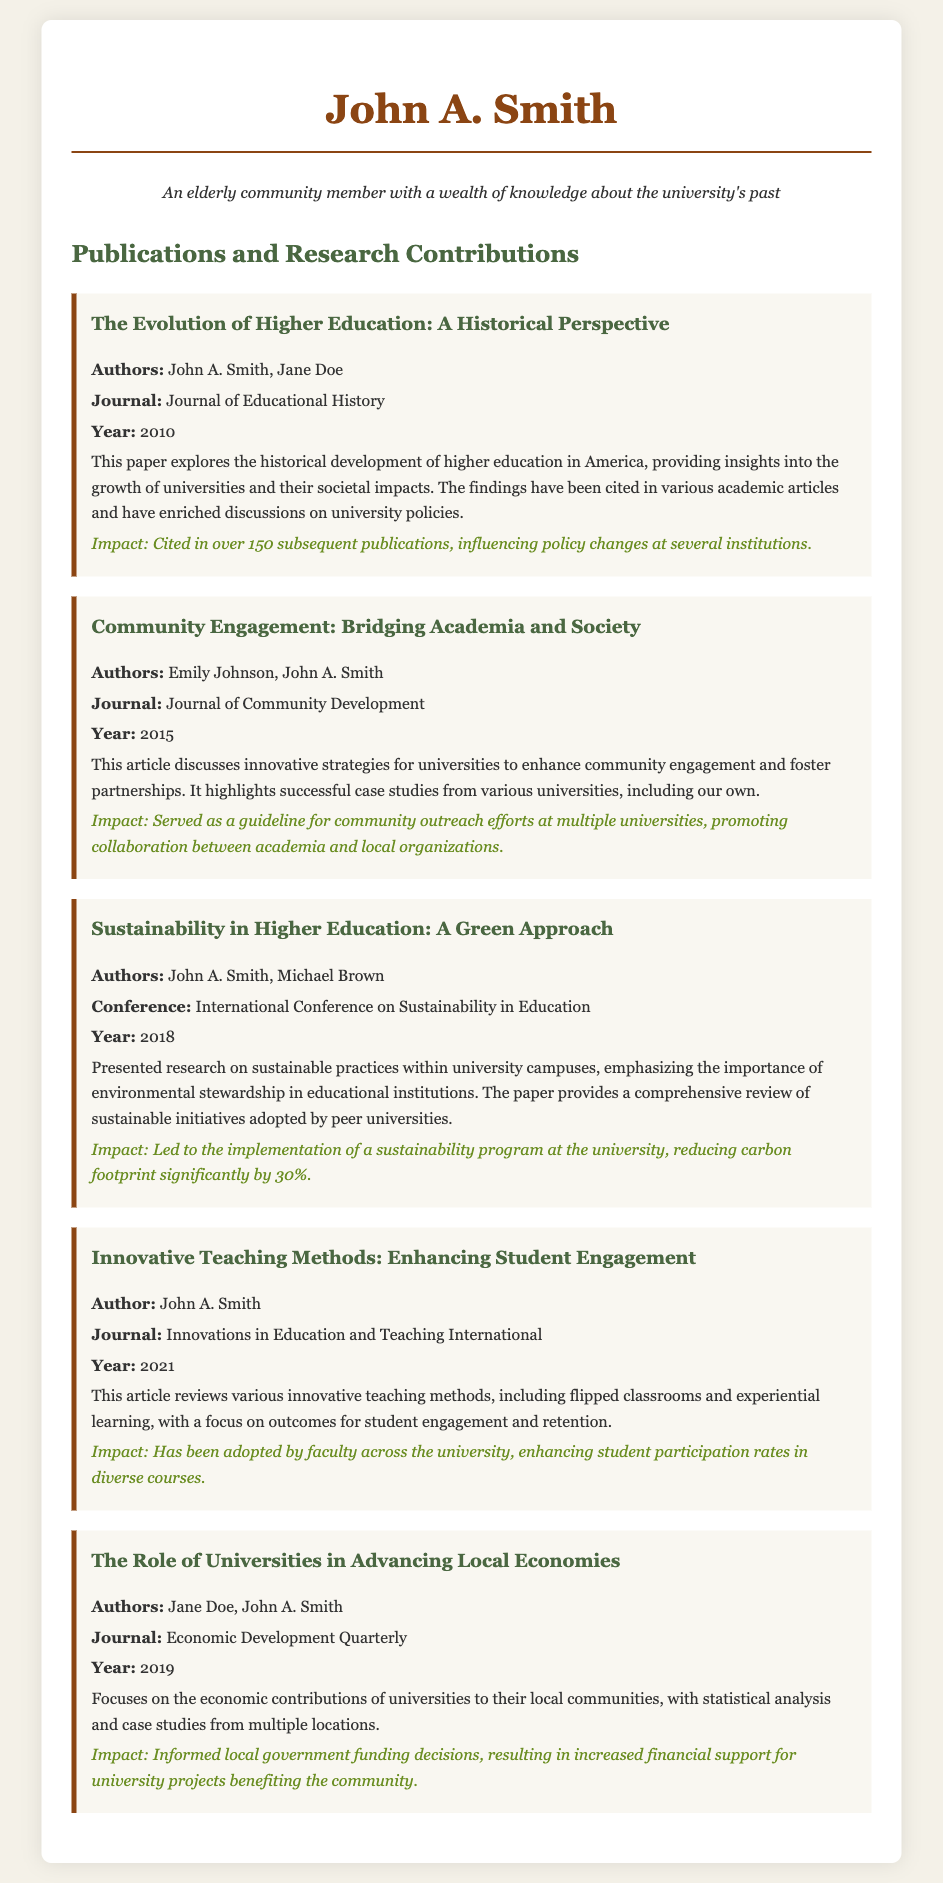What is the title of the first publication? The title of the first publication is provided in the document and is "The Evolution of Higher Education: A Historical Perspective."
Answer: The Evolution of Higher Education: A Historical Perspective Who are the co-authors of the publication titled "Community Engagement: Bridging Academia and Society"? The names of the authors for this publication are mentioned, including John A. Smith and Emily Johnson.
Answer: Emily Johnson What year was the article "Innovative Teaching Methods: Enhancing Student Engagement" published? The document states the publication year for this article as 2021.
Answer: 2021 What was the impact of the paper presented at the International Conference on Sustainability in Education? The impact described in the document includes leading to the implementation of a sustainability program at the university, resulting in a significant carbon footprint reduction.
Answer: Reducing carbon footprint significantly by 30% In which journal was "The Role of Universities in Advancing Local Economies" published? The publication details provide the name of the journal as "Economic Development Quarterly."
Answer: Economic Development Quarterly How many subsequent publications cited "The Evolution of Higher Education: A Historical Perspective"? The document includes a specific mention of the number of times this publication has been cited, which is 150.
Answer: 150 What is the primary focus of the publication "Sustainability in Higher Education: A Green Approach"? The document describes the focus of this publication on sustainable practices within university campuses and emphasizes environmental stewardship.
Answer: Sustainable practices within university campuses What innovative teaching methods are reviewed in the 2021 article authored solely by John A. Smith? The reviewed teaching methods specified in the document include flipped classrooms and experiential learning.
Answer: Flipped classrooms and experiential learning 